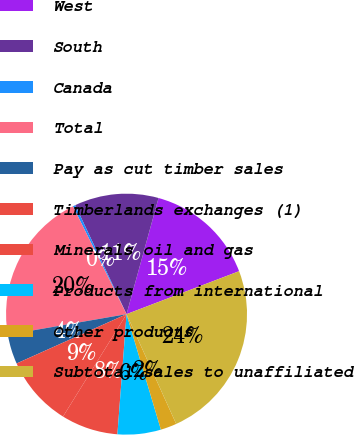Convert chart. <chart><loc_0><loc_0><loc_500><loc_500><pie_chart><fcel>West<fcel>South<fcel>Canada<fcel>Total<fcel>Pay as cut timber sales<fcel>Timberlands exchanges (1)<fcel>Minerals oil and gas<fcel>Products from international<fcel>Other products<fcel>Subtotal sales to unaffiliated<nl><fcel>14.92%<fcel>11.28%<fcel>0.34%<fcel>20.39%<fcel>3.98%<fcel>9.45%<fcel>7.63%<fcel>5.81%<fcel>2.16%<fcel>24.04%<nl></chart> 